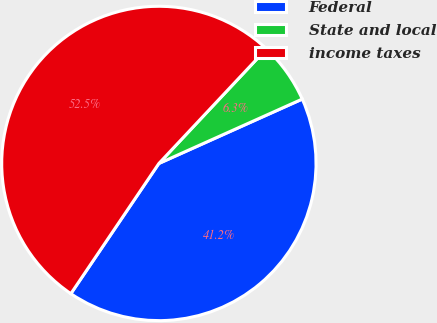Convert chart to OTSL. <chart><loc_0><loc_0><loc_500><loc_500><pie_chart><fcel>Federal<fcel>State and local<fcel>income taxes<nl><fcel>41.18%<fcel>6.29%<fcel>52.53%<nl></chart> 